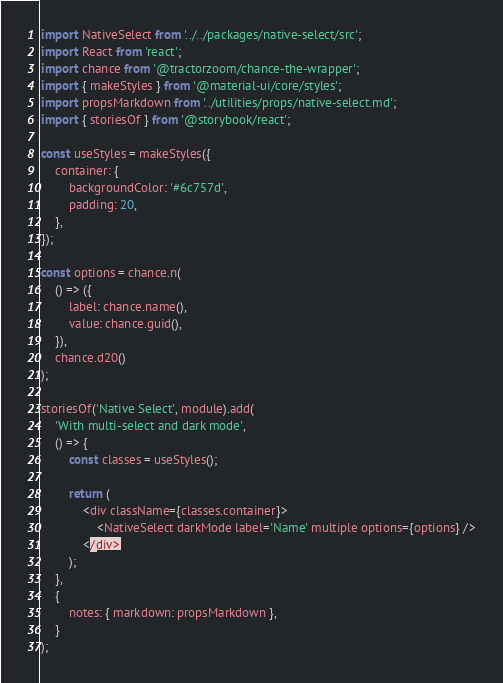<code> <loc_0><loc_0><loc_500><loc_500><_JavaScript_>import NativeSelect from '../../packages/native-select/src';
import React from 'react';
import chance from '@tractorzoom/chance-the-wrapper';
import { makeStyles } from '@material-ui/core/styles';
import propsMarkdown from '../utilities/props/native-select.md';
import { storiesOf } from '@storybook/react';

const useStyles = makeStyles({
    container: {
        backgroundColor: '#6c757d',
        padding: 20,
    },
});

const options = chance.n(
    () => ({
        label: chance.name(),
        value: chance.guid(),
    }),
    chance.d20()
);

storiesOf('Native Select', module).add(
    'With multi-select and dark mode',
    () => {
        const classes = useStyles();

        return (
            <div className={classes.container}>
                <NativeSelect darkMode label='Name' multiple options={options} />
            </div>
        );
    },
    {
        notes: { markdown: propsMarkdown },
    }
);
</code> 